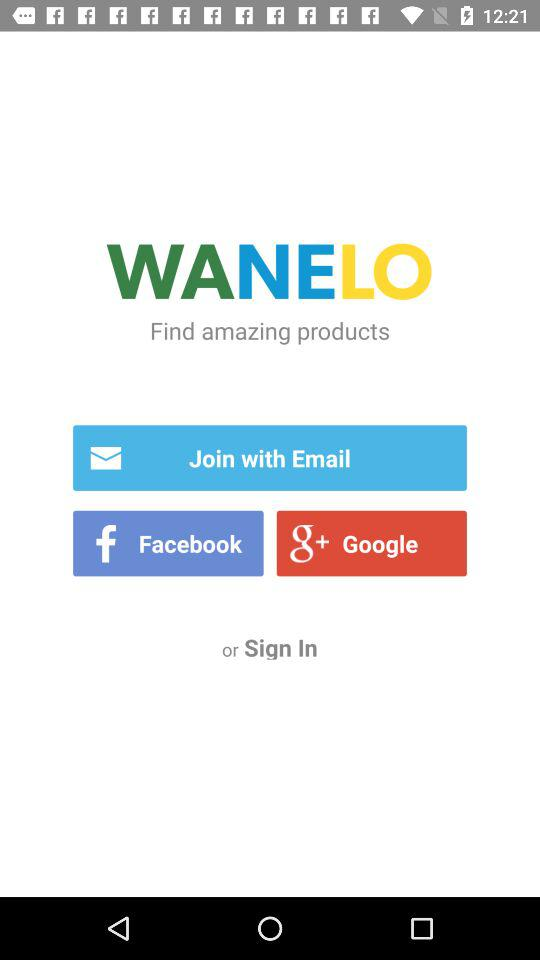What is the app name? The app name is "WANELO". 